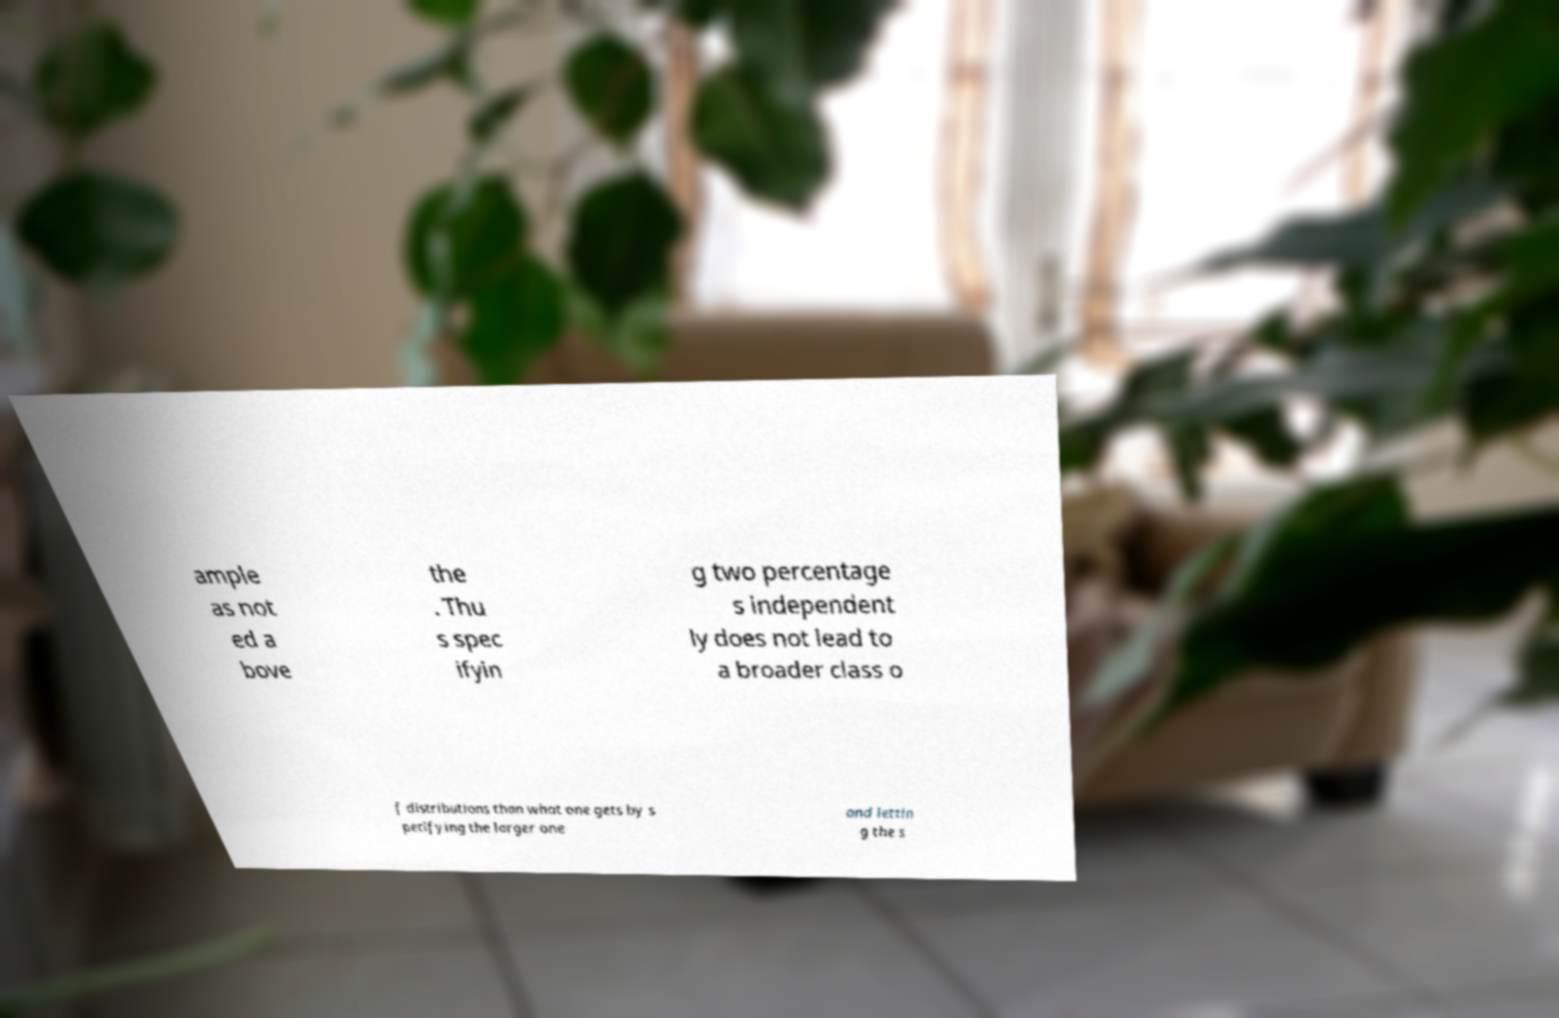There's text embedded in this image that I need extracted. Can you transcribe it verbatim? ample as not ed a bove the . Thu s spec ifyin g two percentage s independent ly does not lead to a broader class o f distributions than what one gets by s pecifying the larger one and lettin g the s 